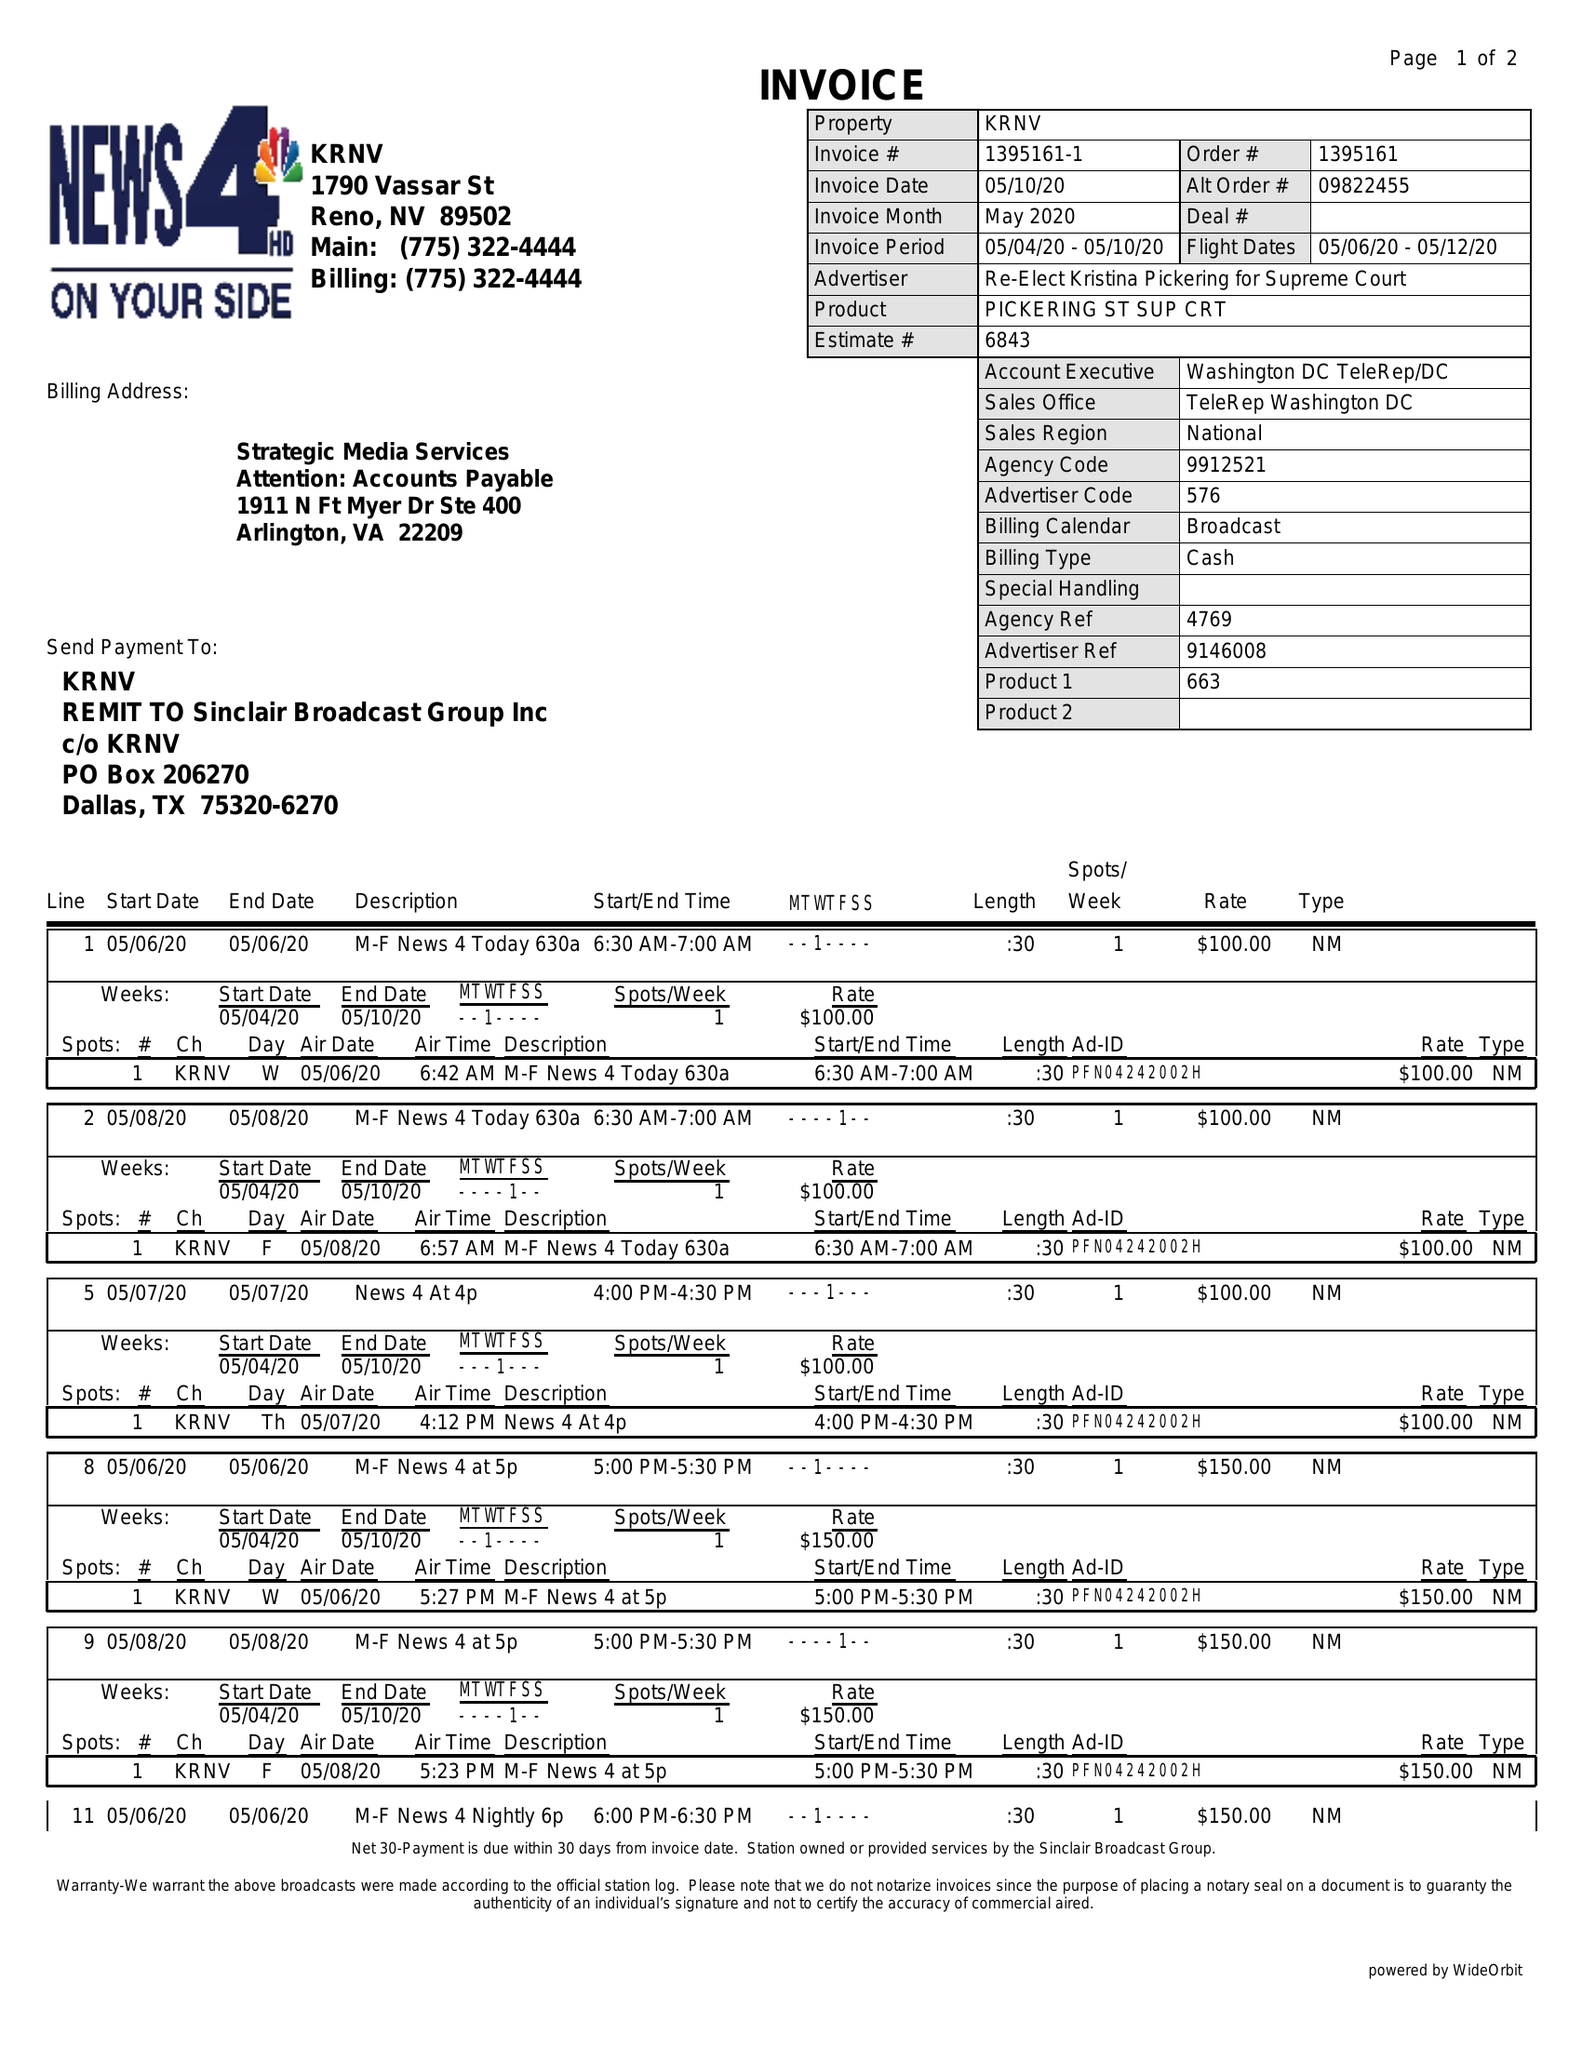What is the value for the contract_num?
Answer the question using a single word or phrase. 1395161 